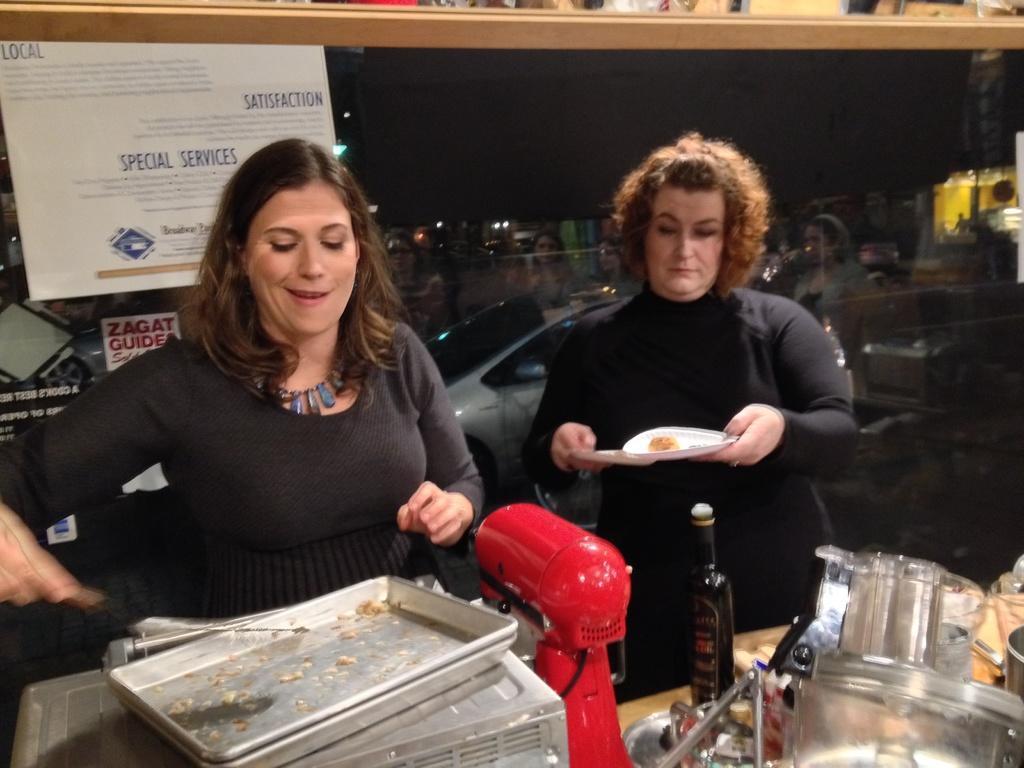Please provide a concise description of this image. Here we can see tray, bottle and objects. This woman is holding an object. Posters are on glass. Through this glass we can see vehicle. On this glass there is a reflection of people. 